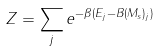<formula> <loc_0><loc_0><loc_500><loc_500>Z = \sum _ { j } { e ^ { - \beta ( E _ { j } - B ( M _ { s } ) _ { j } ) } }</formula> 